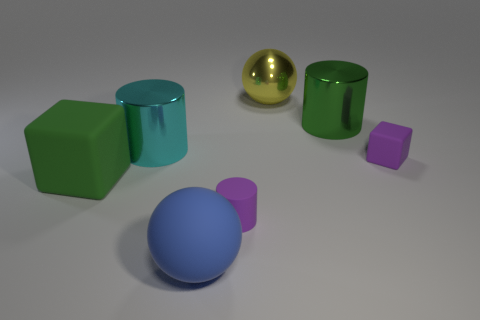Subtract all large shiny cylinders. How many cylinders are left? 1 Subtract all green blocks. How many blocks are left? 1 Add 1 tiny blue shiny cubes. How many objects exist? 8 Subtract all cubes. How many objects are left? 5 Subtract 0 brown spheres. How many objects are left? 7 Subtract 2 spheres. How many spheres are left? 0 Subtract all gray cylinders. Subtract all red cubes. How many cylinders are left? 3 Subtract all purple rubber blocks. Subtract all small yellow metallic cylinders. How many objects are left? 6 Add 5 large cyan objects. How many large cyan objects are left? 6 Add 3 small matte cubes. How many small matte cubes exist? 4 